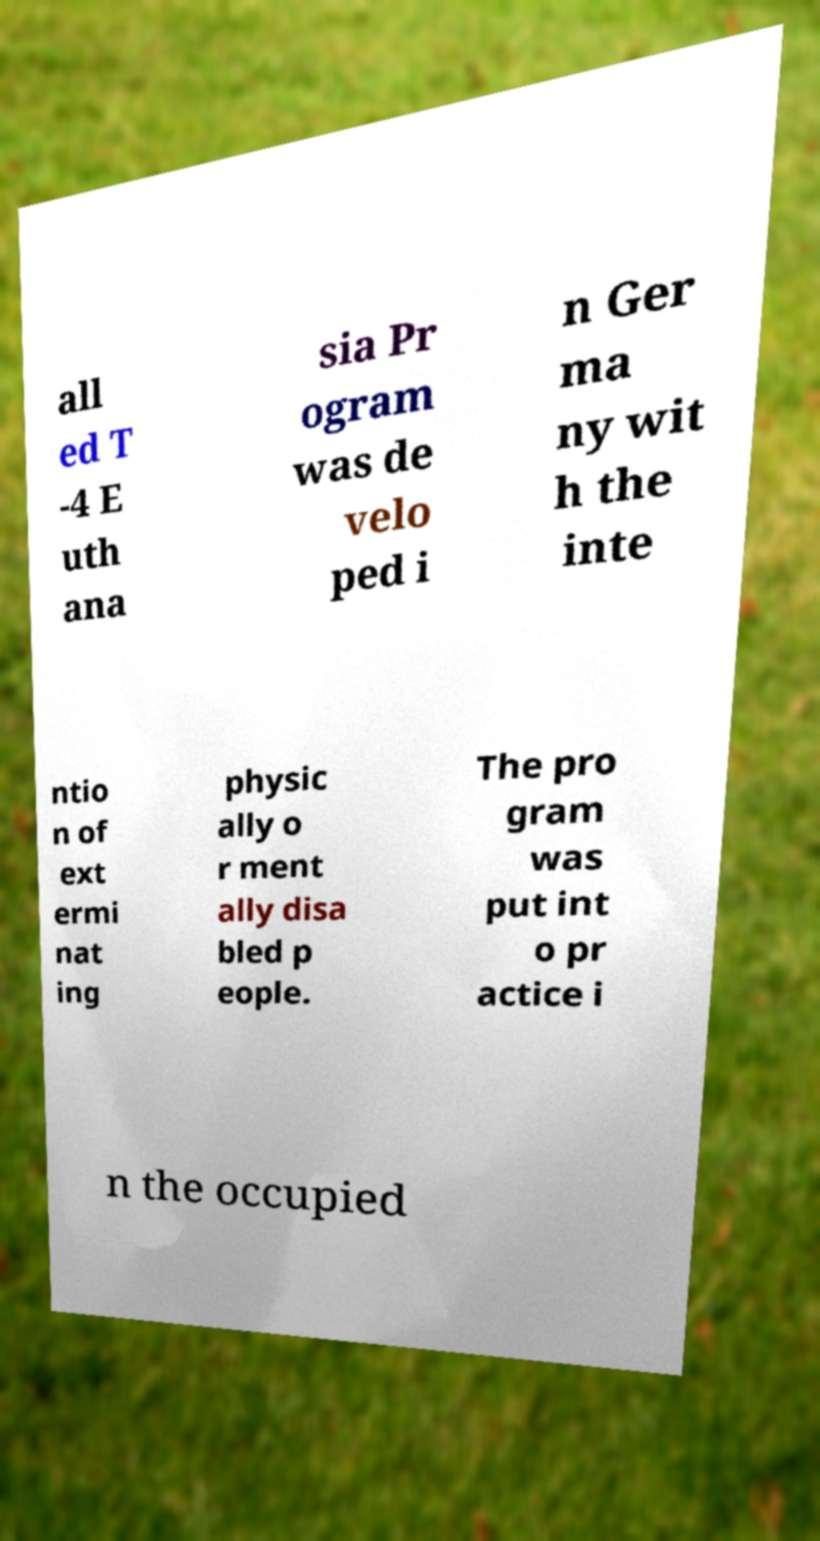Please read and relay the text visible in this image. What does it say? all ed T -4 E uth ana sia Pr ogram was de velo ped i n Ger ma ny wit h the inte ntio n of ext ermi nat ing physic ally o r ment ally disa bled p eople. The pro gram was put int o pr actice i n the occupied 